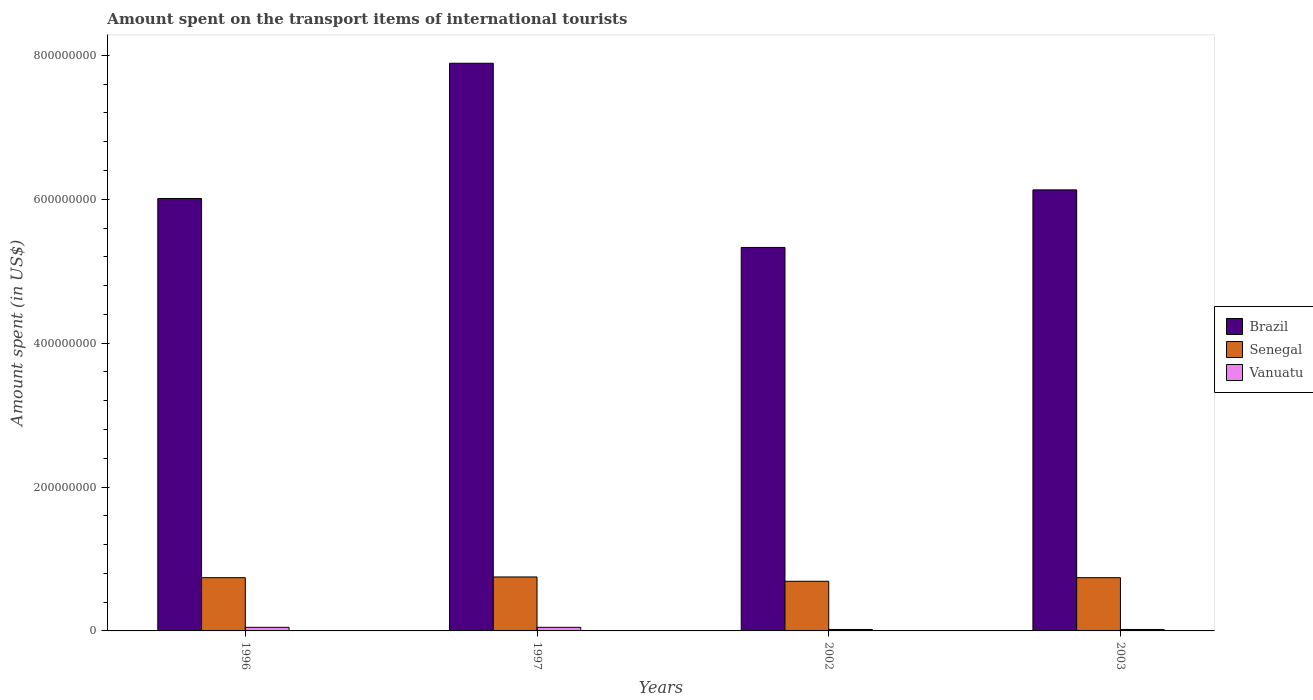How many different coloured bars are there?
Your answer should be compact. 3. Are the number of bars per tick equal to the number of legend labels?
Your answer should be very brief. Yes. What is the amount spent on the transport items of international tourists in Brazil in 2003?
Provide a succinct answer. 6.13e+08. Across all years, what is the maximum amount spent on the transport items of international tourists in Brazil?
Provide a short and direct response. 7.89e+08. Across all years, what is the minimum amount spent on the transport items of international tourists in Senegal?
Provide a short and direct response. 6.90e+07. In which year was the amount spent on the transport items of international tourists in Senegal maximum?
Your answer should be compact. 1997. What is the total amount spent on the transport items of international tourists in Brazil in the graph?
Your response must be concise. 2.54e+09. What is the difference between the amount spent on the transport items of international tourists in Brazil in 1996 and that in 2003?
Provide a succinct answer. -1.20e+07. What is the difference between the amount spent on the transport items of international tourists in Brazil in 2002 and the amount spent on the transport items of international tourists in Senegal in 1996?
Provide a short and direct response. 4.59e+08. What is the average amount spent on the transport items of international tourists in Vanuatu per year?
Your answer should be very brief. 3.50e+06. In the year 1996, what is the difference between the amount spent on the transport items of international tourists in Brazil and amount spent on the transport items of international tourists in Senegal?
Make the answer very short. 5.27e+08. In how many years, is the amount spent on the transport items of international tourists in Vanuatu greater than 720000000 US$?
Offer a terse response. 0. Is the amount spent on the transport items of international tourists in Brazil in 1997 less than that in 2003?
Ensure brevity in your answer.  No. What is the difference between the highest and the second highest amount spent on the transport items of international tourists in Senegal?
Provide a succinct answer. 1.00e+06. What is the difference between the highest and the lowest amount spent on the transport items of international tourists in Brazil?
Your response must be concise. 2.56e+08. What does the 3rd bar from the left in 1997 represents?
Ensure brevity in your answer.  Vanuatu. What does the 2nd bar from the right in 2003 represents?
Offer a terse response. Senegal. How many bars are there?
Offer a very short reply. 12. How many years are there in the graph?
Keep it short and to the point. 4. Does the graph contain any zero values?
Your response must be concise. No. Does the graph contain grids?
Offer a very short reply. No. How are the legend labels stacked?
Ensure brevity in your answer.  Vertical. What is the title of the graph?
Your answer should be compact. Amount spent on the transport items of international tourists. What is the label or title of the Y-axis?
Make the answer very short. Amount spent (in US$). What is the Amount spent (in US$) of Brazil in 1996?
Keep it short and to the point. 6.01e+08. What is the Amount spent (in US$) in Senegal in 1996?
Provide a short and direct response. 7.40e+07. What is the Amount spent (in US$) of Brazil in 1997?
Your answer should be compact. 7.89e+08. What is the Amount spent (in US$) of Senegal in 1997?
Your response must be concise. 7.50e+07. What is the Amount spent (in US$) in Vanuatu in 1997?
Ensure brevity in your answer.  5.00e+06. What is the Amount spent (in US$) in Brazil in 2002?
Ensure brevity in your answer.  5.33e+08. What is the Amount spent (in US$) in Senegal in 2002?
Offer a very short reply. 6.90e+07. What is the Amount spent (in US$) in Vanuatu in 2002?
Offer a terse response. 2.00e+06. What is the Amount spent (in US$) in Brazil in 2003?
Keep it short and to the point. 6.13e+08. What is the Amount spent (in US$) of Senegal in 2003?
Keep it short and to the point. 7.40e+07. What is the Amount spent (in US$) in Vanuatu in 2003?
Your response must be concise. 2.00e+06. Across all years, what is the maximum Amount spent (in US$) of Brazil?
Give a very brief answer. 7.89e+08. Across all years, what is the maximum Amount spent (in US$) of Senegal?
Offer a very short reply. 7.50e+07. Across all years, what is the maximum Amount spent (in US$) of Vanuatu?
Provide a succinct answer. 5.00e+06. Across all years, what is the minimum Amount spent (in US$) of Brazil?
Your response must be concise. 5.33e+08. Across all years, what is the minimum Amount spent (in US$) in Senegal?
Provide a succinct answer. 6.90e+07. Across all years, what is the minimum Amount spent (in US$) of Vanuatu?
Give a very brief answer. 2.00e+06. What is the total Amount spent (in US$) of Brazil in the graph?
Your response must be concise. 2.54e+09. What is the total Amount spent (in US$) of Senegal in the graph?
Offer a terse response. 2.92e+08. What is the total Amount spent (in US$) of Vanuatu in the graph?
Your answer should be compact. 1.40e+07. What is the difference between the Amount spent (in US$) in Brazil in 1996 and that in 1997?
Your response must be concise. -1.88e+08. What is the difference between the Amount spent (in US$) of Senegal in 1996 and that in 1997?
Your response must be concise. -1.00e+06. What is the difference between the Amount spent (in US$) of Vanuatu in 1996 and that in 1997?
Make the answer very short. 0. What is the difference between the Amount spent (in US$) in Brazil in 1996 and that in 2002?
Keep it short and to the point. 6.80e+07. What is the difference between the Amount spent (in US$) in Senegal in 1996 and that in 2002?
Give a very brief answer. 5.00e+06. What is the difference between the Amount spent (in US$) of Brazil in 1996 and that in 2003?
Ensure brevity in your answer.  -1.20e+07. What is the difference between the Amount spent (in US$) of Senegal in 1996 and that in 2003?
Your response must be concise. 0. What is the difference between the Amount spent (in US$) in Vanuatu in 1996 and that in 2003?
Your answer should be very brief. 3.00e+06. What is the difference between the Amount spent (in US$) of Brazil in 1997 and that in 2002?
Your response must be concise. 2.56e+08. What is the difference between the Amount spent (in US$) in Senegal in 1997 and that in 2002?
Provide a short and direct response. 6.00e+06. What is the difference between the Amount spent (in US$) of Vanuatu in 1997 and that in 2002?
Your answer should be compact. 3.00e+06. What is the difference between the Amount spent (in US$) of Brazil in 1997 and that in 2003?
Provide a succinct answer. 1.76e+08. What is the difference between the Amount spent (in US$) in Senegal in 1997 and that in 2003?
Your response must be concise. 1.00e+06. What is the difference between the Amount spent (in US$) in Brazil in 2002 and that in 2003?
Offer a terse response. -8.00e+07. What is the difference between the Amount spent (in US$) of Senegal in 2002 and that in 2003?
Give a very brief answer. -5.00e+06. What is the difference between the Amount spent (in US$) in Brazil in 1996 and the Amount spent (in US$) in Senegal in 1997?
Offer a terse response. 5.26e+08. What is the difference between the Amount spent (in US$) of Brazil in 1996 and the Amount spent (in US$) of Vanuatu in 1997?
Provide a short and direct response. 5.96e+08. What is the difference between the Amount spent (in US$) in Senegal in 1996 and the Amount spent (in US$) in Vanuatu in 1997?
Your answer should be compact. 6.90e+07. What is the difference between the Amount spent (in US$) in Brazil in 1996 and the Amount spent (in US$) in Senegal in 2002?
Your response must be concise. 5.32e+08. What is the difference between the Amount spent (in US$) of Brazil in 1996 and the Amount spent (in US$) of Vanuatu in 2002?
Your response must be concise. 5.99e+08. What is the difference between the Amount spent (in US$) in Senegal in 1996 and the Amount spent (in US$) in Vanuatu in 2002?
Offer a terse response. 7.20e+07. What is the difference between the Amount spent (in US$) in Brazil in 1996 and the Amount spent (in US$) in Senegal in 2003?
Offer a terse response. 5.27e+08. What is the difference between the Amount spent (in US$) in Brazil in 1996 and the Amount spent (in US$) in Vanuatu in 2003?
Your answer should be compact. 5.99e+08. What is the difference between the Amount spent (in US$) in Senegal in 1996 and the Amount spent (in US$) in Vanuatu in 2003?
Offer a very short reply. 7.20e+07. What is the difference between the Amount spent (in US$) of Brazil in 1997 and the Amount spent (in US$) of Senegal in 2002?
Keep it short and to the point. 7.20e+08. What is the difference between the Amount spent (in US$) of Brazil in 1997 and the Amount spent (in US$) of Vanuatu in 2002?
Offer a terse response. 7.87e+08. What is the difference between the Amount spent (in US$) in Senegal in 1997 and the Amount spent (in US$) in Vanuatu in 2002?
Offer a very short reply. 7.30e+07. What is the difference between the Amount spent (in US$) of Brazil in 1997 and the Amount spent (in US$) of Senegal in 2003?
Offer a terse response. 7.15e+08. What is the difference between the Amount spent (in US$) in Brazil in 1997 and the Amount spent (in US$) in Vanuatu in 2003?
Offer a terse response. 7.87e+08. What is the difference between the Amount spent (in US$) in Senegal in 1997 and the Amount spent (in US$) in Vanuatu in 2003?
Make the answer very short. 7.30e+07. What is the difference between the Amount spent (in US$) in Brazil in 2002 and the Amount spent (in US$) in Senegal in 2003?
Your response must be concise. 4.59e+08. What is the difference between the Amount spent (in US$) in Brazil in 2002 and the Amount spent (in US$) in Vanuatu in 2003?
Your response must be concise. 5.31e+08. What is the difference between the Amount spent (in US$) in Senegal in 2002 and the Amount spent (in US$) in Vanuatu in 2003?
Your response must be concise. 6.70e+07. What is the average Amount spent (in US$) in Brazil per year?
Ensure brevity in your answer.  6.34e+08. What is the average Amount spent (in US$) of Senegal per year?
Ensure brevity in your answer.  7.30e+07. What is the average Amount spent (in US$) of Vanuatu per year?
Make the answer very short. 3.50e+06. In the year 1996, what is the difference between the Amount spent (in US$) of Brazil and Amount spent (in US$) of Senegal?
Your answer should be very brief. 5.27e+08. In the year 1996, what is the difference between the Amount spent (in US$) of Brazil and Amount spent (in US$) of Vanuatu?
Provide a short and direct response. 5.96e+08. In the year 1996, what is the difference between the Amount spent (in US$) in Senegal and Amount spent (in US$) in Vanuatu?
Your answer should be very brief. 6.90e+07. In the year 1997, what is the difference between the Amount spent (in US$) of Brazil and Amount spent (in US$) of Senegal?
Your response must be concise. 7.14e+08. In the year 1997, what is the difference between the Amount spent (in US$) of Brazil and Amount spent (in US$) of Vanuatu?
Provide a short and direct response. 7.84e+08. In the year 1997, what is the difference between the Amount spent (in US$) of Senegal and Amount spent (in US$) of Vanuatu?
Give a very brief answer. 7.00e+07. In the year 2002, what is the difference between the Amount spent (in US$) of Brazil and Amount spent (in US$) of Senegal?
Offer a very short reply. 4.64e+08. In the year 2002, what is the difference between the Amount spent (in US$) of Brazil and Amount spent (in US$) of Vanuatu?
Your answer should be compact. 5.31e+08. In the year 2002, what is the difference between the Amount spent (in US$) of Senegal and Amount spent (in US$) of Vanuatu?
Your answer should be very brief. 6.70e+07. In the year 2003, what is the difference between the Amount spent (in US$) in Brazil and Amount spent (in US$) in Senegal?
Provide a succinct answer. 5.39e+08. In the year 2003, what is the difference between the Amount spent (in US$) in Brazil and Amount spent (in US$) in Vanuatu?
Your response must be concise. 6.11e+08. In the year 2003, what is the difference between the Amount spent (in US$) of Senegal and Amount spent (in US$) of Vanuatu?
Offer a terse response. 7.20e+07. What is the ratio of the Amount spent (in US$) in Brazil in 1996 to that in 1997?
Your answer should be very brief. 0.76. What is the ratio of the Amount spent (in US$) of Senegal in 1996 to that in 1997?
Your answer should be very brief. 0.99. What is the ratio of the Amount spent (in US$) in Vanuatu in 1996 to that in 1997?
Your answer should be very brief. 1. What is the ratio of the Amount spent (in US$) in Brazil in 1996 to that in 2002?
Your answer should be compact. 1.13. What is the ratio of the Amount spent (in US$) in Senegal in 1996 to that in 2002?
Offer a very short reply. 1.07. What is the ratio of the Amount spent (in US$) of Vanuatu in 1996 to that in 2002?
Ensure brevity in your answer.  2.5. What is the ratio of the Amount spent (in US$) of Brazil in 1996 to that in 2003?
Your response must be concise. 0.98. What is the ratio of the Amount spent (in US$) in Senegal in 1996 to that in 2003?
Your response must be concise. 1. What is the ratio of the Amount spent (in US$) in Vanuatu in 1996 to that in 2003?
Make the answer very short. 2.5. What is the ratio of the Amount spent (in US$) of Brazil in 1997 to that in 2002?
Your response must be concise. 1.48. What is the ratio of the Amount spent (in US$) of Senegal in 1997 to that in 2002?
Your answer should be compact. 1.09. What is the ratio of the Amount spent (in US$) in Vanuatu in 1997 to that in 2002?
Offer a very short reply. 2.5. What is the ratio of the Amount spent (in US$) of Brazil in 1997 to that in 2003?
Make the answer very short. 1.29. What is the ratio of the Amount spent (in US$) in Senegal in 1997 to that in 2003?
Make the answer very short. 1.01. What is the ratio of the Amount spent (in US$) of Vanuatu in 1997 to that in 2003?
Provide a short and direct response. 2.5. What is the ratio of the Amount spent (in US$) in Brazil in 2002 to that in 2003?
Keep it short and to the point. 0.87. What is the ratio of the Amount spent (in US$) of Senegal in 2002 to that in 2003?
Your answer should be very brief. 0.93. What is the difference between the highest and the second highest Amount spent (in US$) of Brazil?
Your answer should be compact. 1.76e+08. What is the difference between the highest and the second highest Amount spent (in US$) of Senegal?
Your response must be concise. 1.00e+06. What is the difference between the highest and the lowest Amount spent (in US$) in Brazil?
Offer a very short reply. 2.56e+08. What is the difference between the highest and the lowest Amount spent (in US$) of Senegal?
Offer a very short reply. 6.00e+06. What is the difference between the highest and the lowest Amount spent (in US$) of Vanuatu?
Keep it short and to the point. 3.00e+06. 